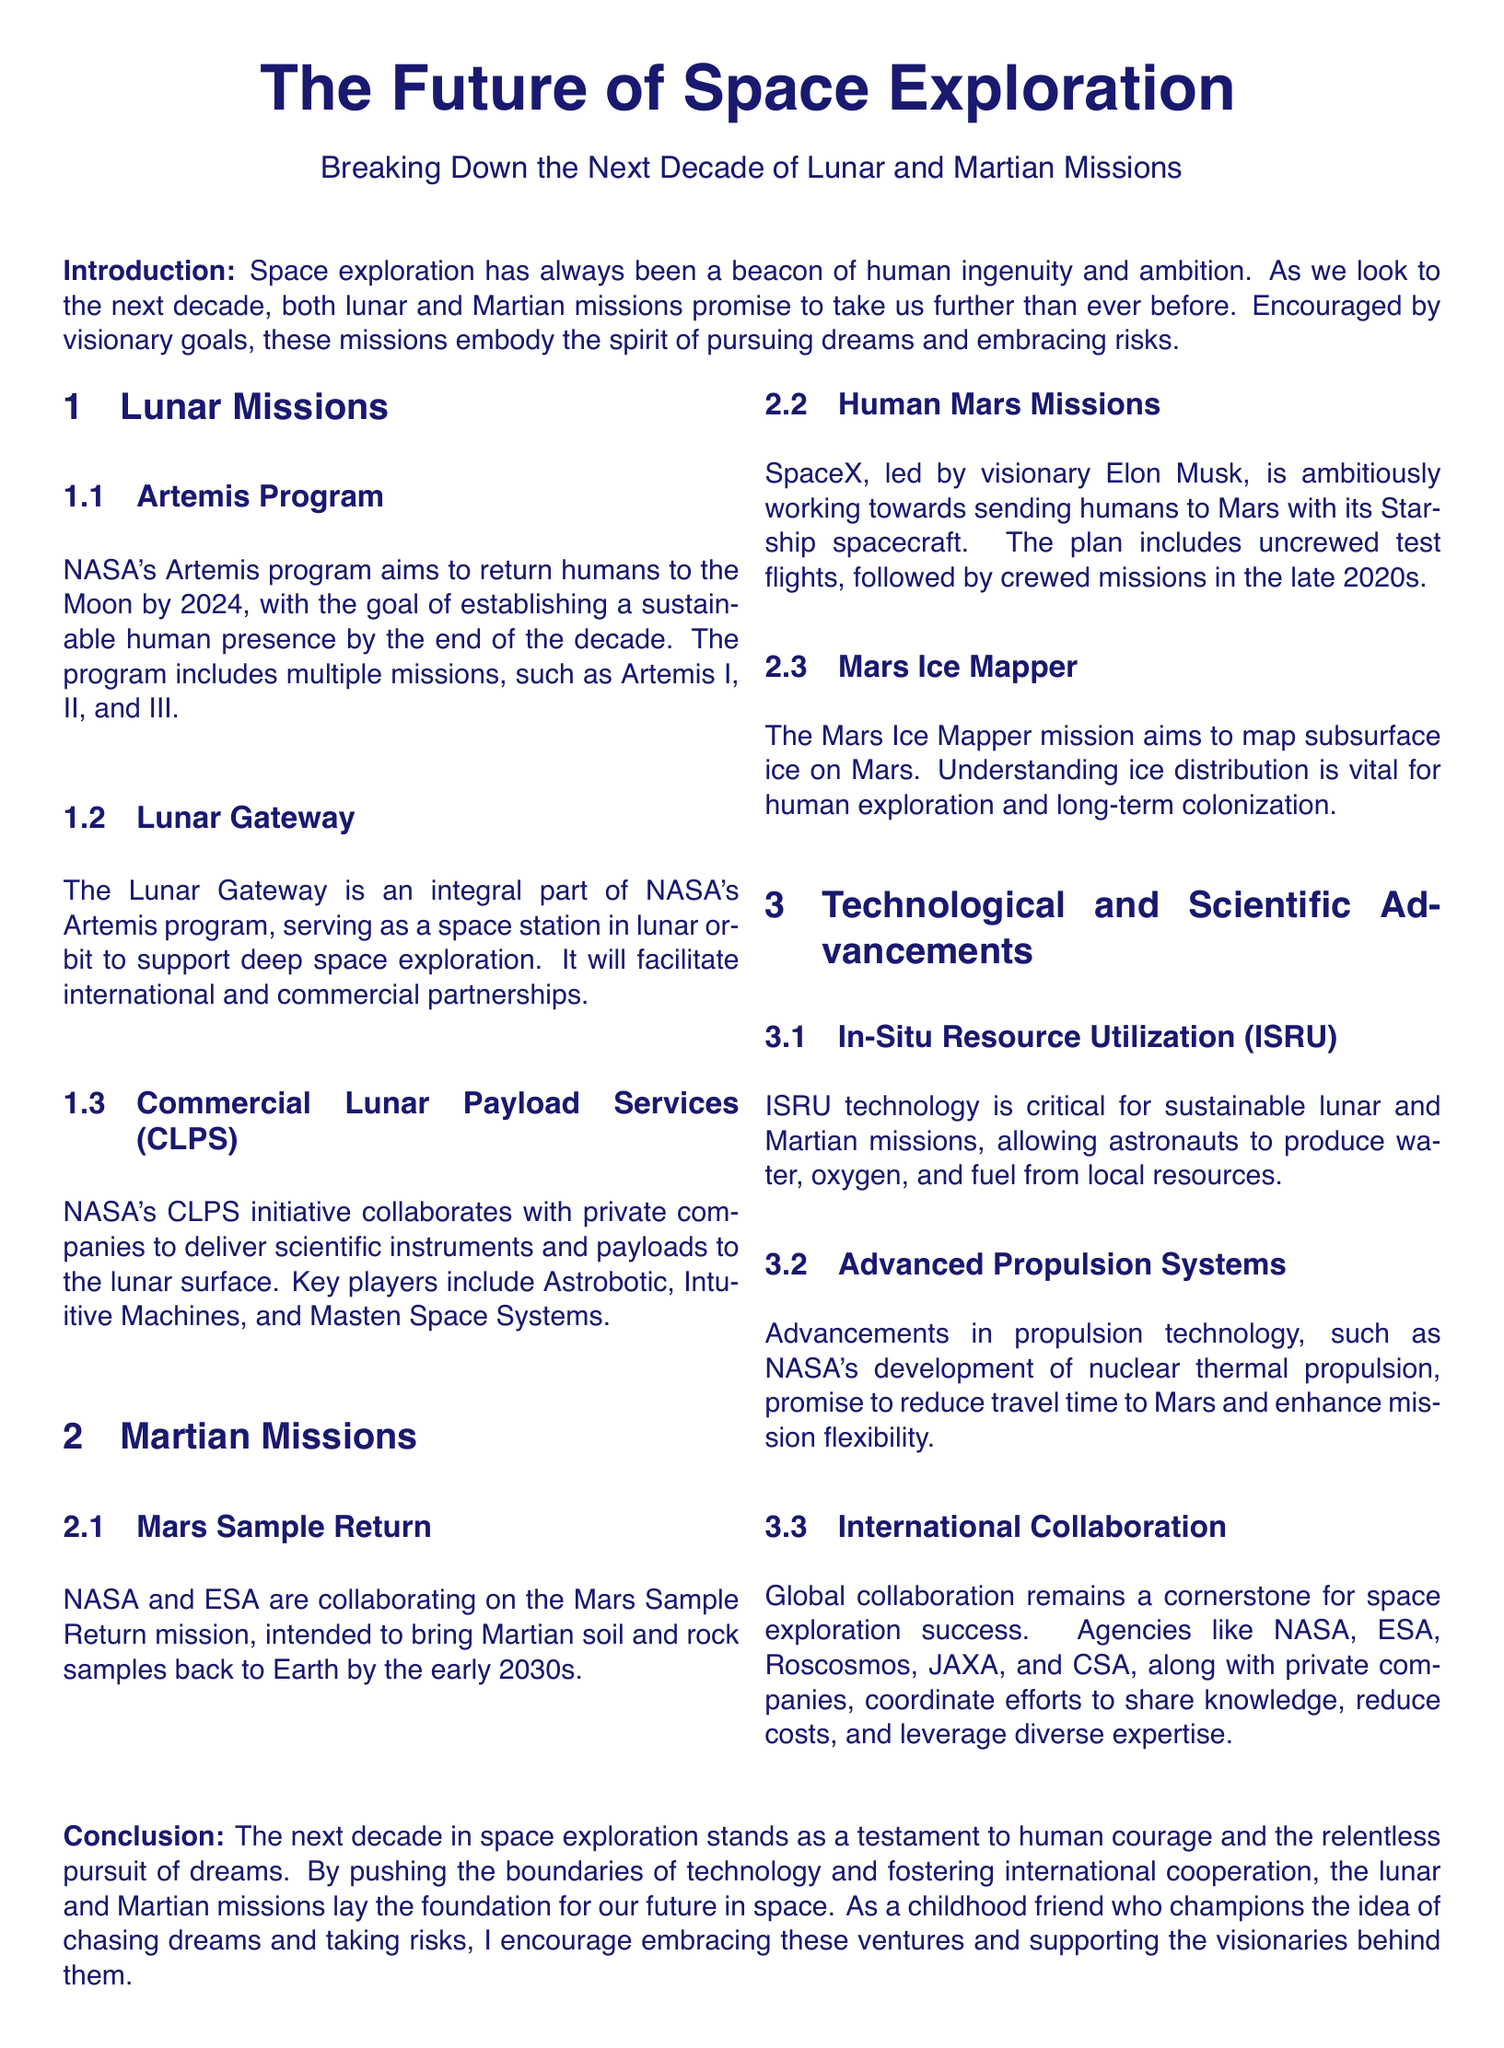What is the name of NASA's program to return humans to the Moon? The document states that NASA's Artemis program aims to return humans to the Moon.
Answer: Artemis program What is the goal of the Lunar Gateway? The document mentions that the Lunar Gateway serves as a space station in lunar orbit to support deep space exploration.
Answer: Support deep space exploration What is the planned timeframe for the Mars Sample Return mission? According to the document, the Mars Sample Return mission is intended to bring samples back to Earth by the early 2030s.
Answer: Early 2030s Which company is leading the effort to send humans to Mars? The document states that SpaceX, led by Elon Musk, is working towards sending humans to Mars.
Answer: SpaceX What technological advancement allows production of resources from local materials? The document highlights In-Situ Resource Utilization (ISRU) as a critical technology for producing water, oxygen, and fuel.
Answer: In-Situ Resource Utilization (ISRU) What is a key aspect of international collaboration in space exploration? The document indicates that global collaboration is crucial for sharing knowledge and reducing costs in space exploration.
Answer: Sharing knowledge and reducing costs When does NASA aim to establish a sustainable human presence on the Moon? The document mentions that NASA aims to establish a sustainable human presence by the end of the decade.
Answer: By the end of the decade What propulsion technology is being developed by NASA? The document notes NASA's development of nuclear thermal propulsion as an advancement in propulsion technology.
Answer: Nuclear thermal propulsion Who are the primary players in NASA's Commercial Lunar Payload Services initiative? According to the document, key players include Astrobotic, Intuitive Machines, and Masten Space Systems.
Answer: Astrobotic, Intuitive Machines, Masten Space Systems 